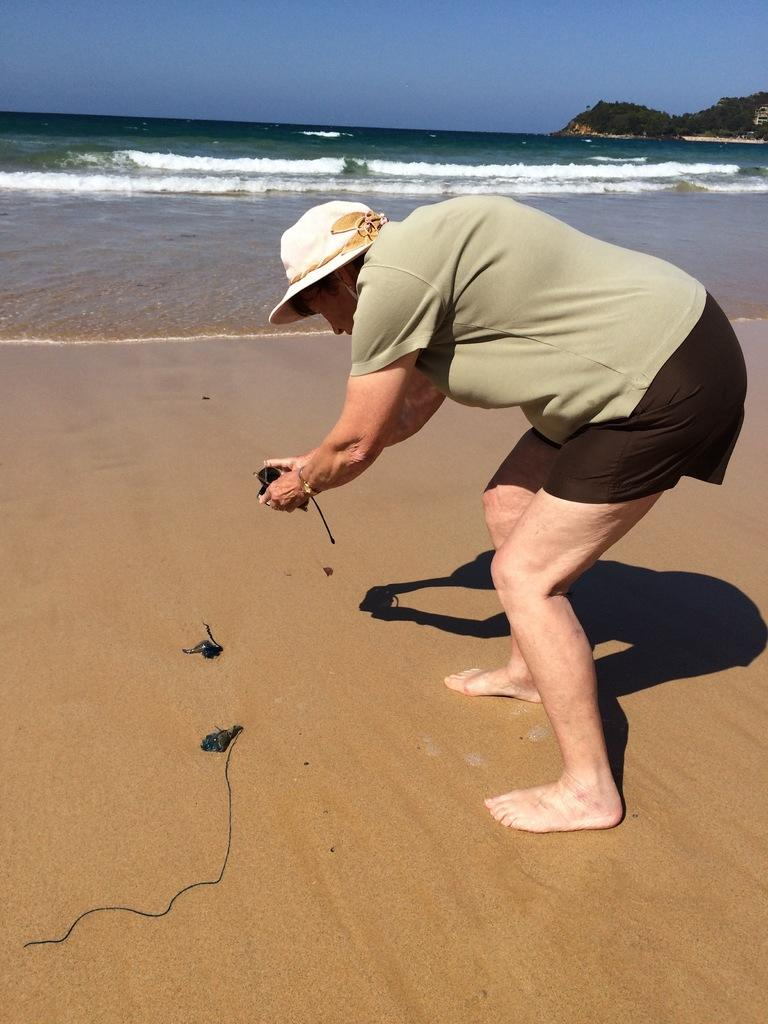Who is the main subject in the image? There is a person in the center of the image. What is the person wearing? The person is wearing a hat. What is the person holding? The person is holding a camera. What can be seen at the bottom of the image? There is water at the bottom of the image. What is present on the ground near the water? There are objects on the ground near the water. What can be seen in the distance in the image? There are hills in the background of the image. What type of fan is being used to cool down the loaf in the image? There is no fan or loaf present in the image. 